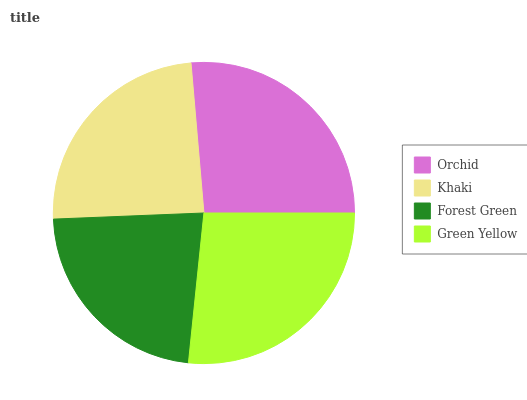Is Forest Green the minimum?
Answer yes or no. Yes. Is Green Yellow the maximum?
Answer yes or no. Yes. Is Khaki the minimum?
Answer yes or no. No. Is Khaki the maximum?
Answer yes or no. No. Is Orchid greater than Khaki?
Answer yes or no. Yes. Is Khaki less than Orchid?
Answer yes or no. Yes. Is Khaki greater than Orchid?
Answer yes or no. No. Is Orchid less than Khaki?
Answer yes or no. No. Is Orchid the high median?
Answer yes or no. Yes. Is Khaki the low median?
Answer yes or no. Yes. Is Green Yellow the high median?
Answer yes or no. No. Is Orchid the low median?
Answer yes or no. No. 